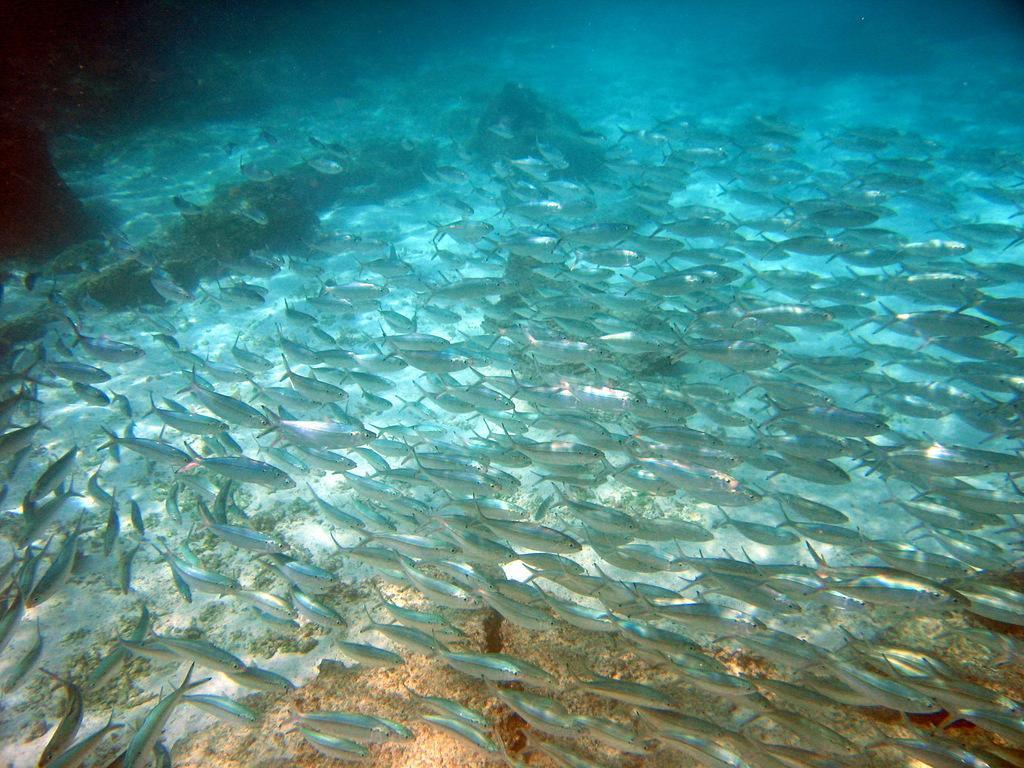Please provide a concise description of this image. In this picture we can see fish in the water and other objects. 